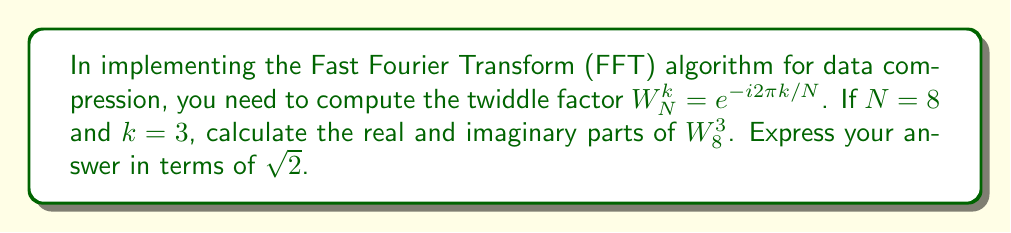Help me with this question. Let's approach this step-by-step:

1) The twiddle factor is defined as $W_N^k = e^{-i2\pi k/N}$

2) In this case, $N = 8$ and $k = 3$, so we have:
   $W_8^3 = e^{-i2\pi 3/8} = e^{-i3\pi/4}$

3) We can express this in terms of cosine and sine:
   $e^{-i3\pi/4} = \cos(-3\pi/4) + i\sin(-3\pi/4)$

4) Recall that cosine is an even function and sine is an odd function:
   $\cos(-3\pi/4) = \cos(3\pi/4)$
   $\sin(-3\pi/4) = -\sin(3\pi/4)$

5) Now, let's calculate $\cos(3\pi/4)$ and $\sin(3\pi/4)$:
   $\cos(3\pi/4) = -\frac{\sqrt{2}}{2}$
   $\sin(3\pi/4) = \frac{\sqrt{2}}{2}$

6) Substituting these values:
   $W_8^3 = -\frac{\sqrt{2}}{2} - i\frac{\sqrt{2}}{2}$

7) Therefore, the real part is $-\frac{\sqrt{2}}{2}$ and the imaginary part is $-\frac{\sqrt{2}}{2}$
Answer: $-\frac{\sqrt{2}}{2} - i\frac{\sqrt{2}}{2}$ 